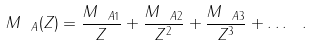Convert formula to latex. <formula><loc_0><loc_0><loc_500><loc_500>M _ { \ A } ( Z ) = \frac { M _ { { \ A } 1 } } { Z } + \frac { M _ { { \ A } 2 } } { Z ^ { 2 } } + \frac { M _ { { \ A } 3 } } { Z ^ { 3 } } + \dots \ .</formula> 